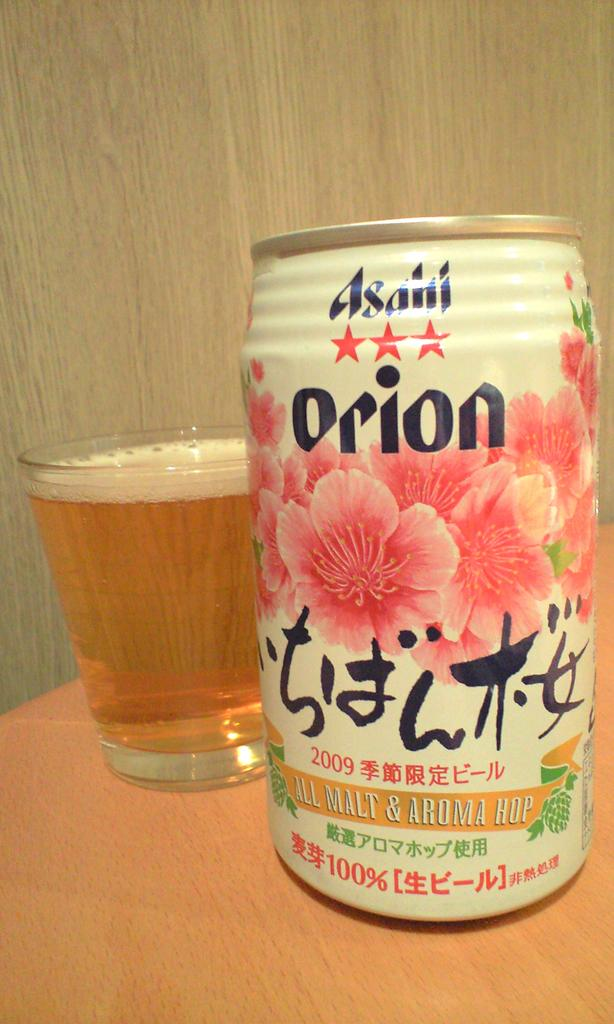What type of surface is visible in the image? There is a wooden surface in the image. What object can be seen on the wooden surface? There is a tin on the wooden surface. What else is on the wooden surface besides the tin? There is a glass with a drink on the wooden surface. How many sheep are visible on the wooden surface in the image? There are no sheep present on the wooden surface in the image. What type of structure is built around the wooden surface in the image? There is no structure built around the wooden surface in the image. 